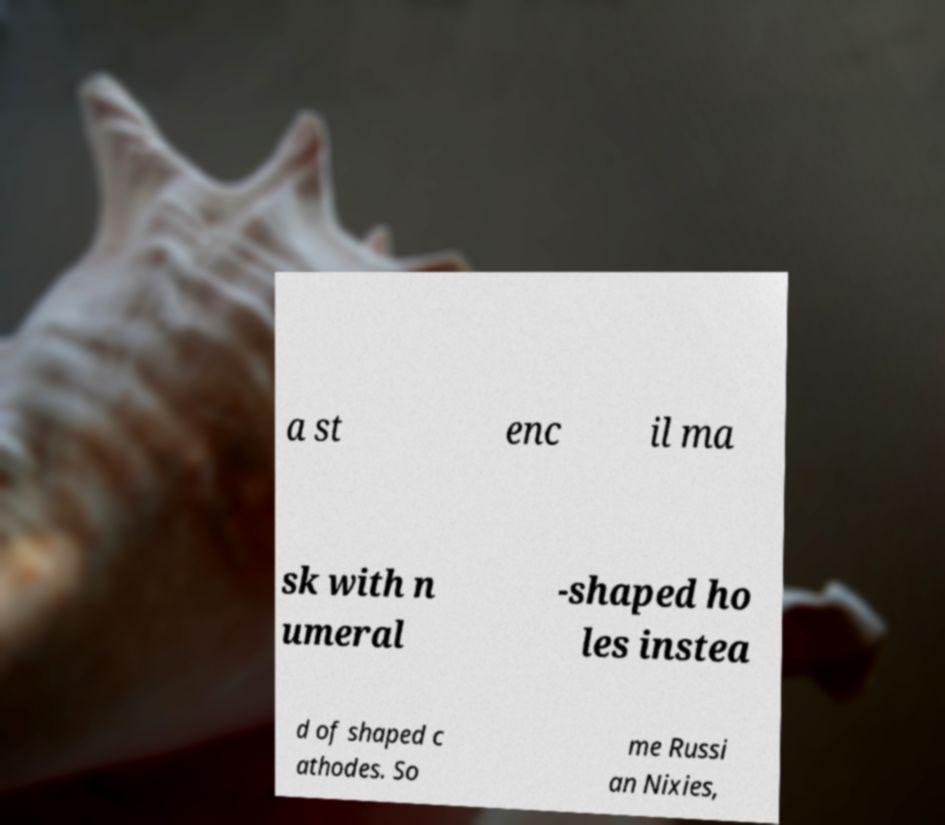Could you assist in decoding the text presented in this image and type it out clearly? a st enc il ma sk with n umeral -shaped ho les instea d of shaped c athodes. So me Russi an Nixies, 